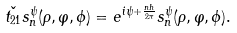Convert formula to latex. <formula><loc_0><loc_0><loc_500><loc_500>\check { t _ { 2 1 } } s _ { n } ^ { \psi } ( \rho , \varphi , \phi ) = e ^ { i \psi + \frac { n h } { 2 \pi } } s _ { n } ^ { \psi } ( \rho , \varphi , \phi ) .</formula> 